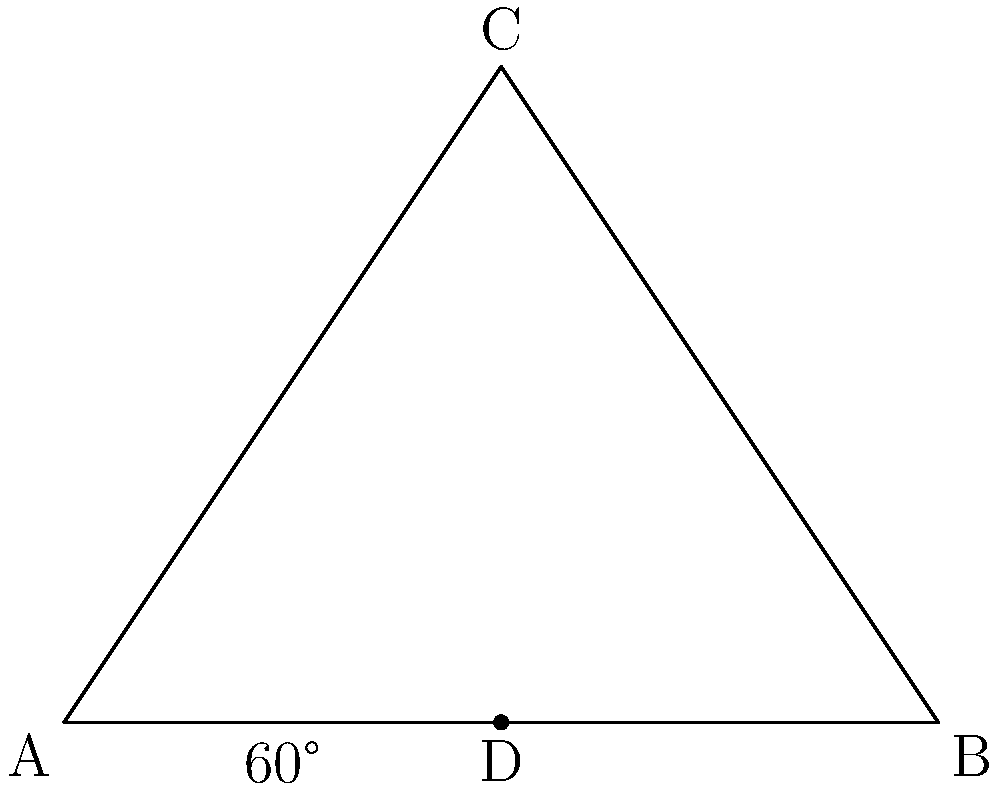In a traditional Pochampally Ikat fabric design, a triangular pattern is observed. If one of the angles in this triangle is 60°, and the triangle is isosceles with AC = BC, what is the measure of angle ACB? Let's approach this step-by-step:

1) In the triangle ABC, we're given that:
   - Angle BAD is 60°
   - AC = BC (isosceles triangle)

2) In an isosceles triangle, the angles opposite the equal sides are equal. So, angle BAC = angle ABC.

3) Let's call the measure of angle BAC as x°.

4) We know that the sum of angles in a triangle is always 180°. So:
   $$60° + x° + x° = 180°$$

5) Simplifying:
   $$60° + 2x° = 180°$$

6) Subtracting 60° from both sides:
   $$2x° = 120°$$

7) Dividing both sides by 2:
   $$x° = 60°$$

8) So, angle BAC = angle ABC = 60°

9) Now, we can find angle ACB:
   $$ACB = 180° - (BAC + ABC) = 180° - (60° + 60°) = 60°$$

Therefore, the measure of angle ACB is 60°.
Answer: 60° 